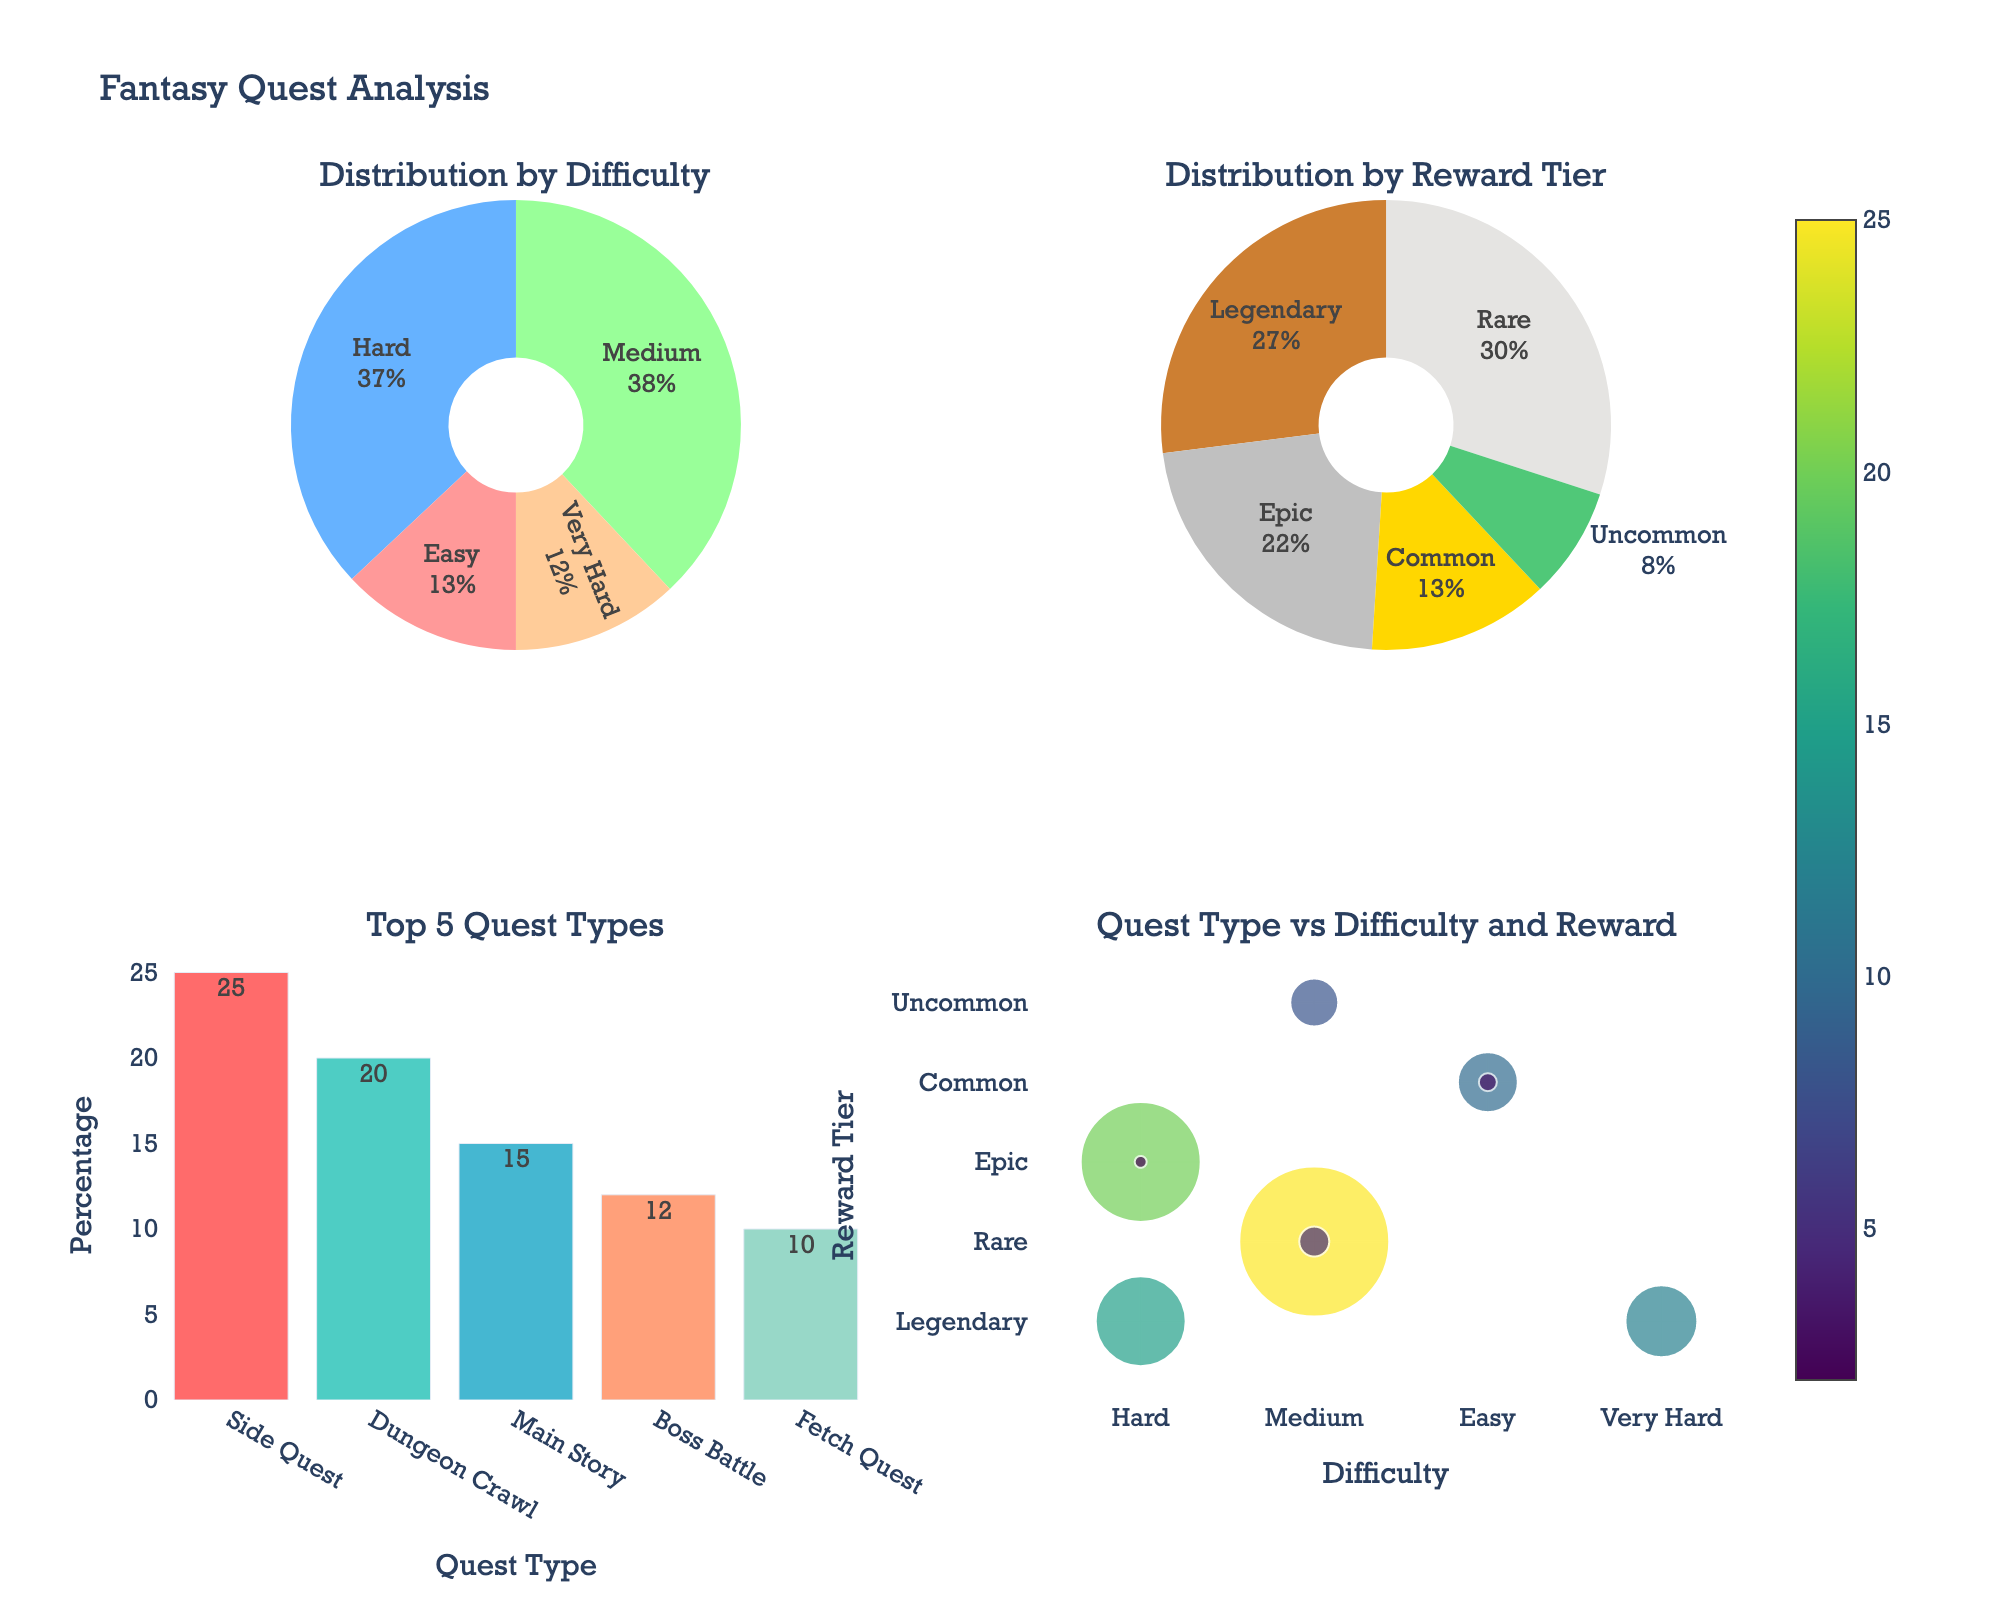What's the most common difficulty level for quests? In the first pie chart, "Distribution by Difficulty," the largest slice represents the "Hard" category, which contributes the most to the percentage.
Answer: Hard Which reward tier has the highest percentage of quests? In the second pie chart, "Distribution by Reward Tier," the biggest section belongs to the "Rare" reward tier.
Answer: Rare Which quest type has the highest percentage according to the bar chart? The bar chart for "Top 5 Quest Types" shows the tallest bar for "Side Quest," indicating it has the highest percentage.
Answer: Side Quest What percentage of quests are considered "Legendary" in terms of rewards? The second pie chart shows two "Legendary" sections: one in "Main Story" (15%) and one in "Boss Battle" (12%). Adding these gives 15 + 12 = 27.
Answer: 27% Which quest type in the "Top 5 Quest Types" has the smallest percentage? According to the bar chart, "Puzzle Solving" has the smallest bar among the "Top 5 Quest Types," representing the smallest percentage.
Answer: Puzzle Solving How do the percentages of "Dungeon Crawl" and "Boss Battle" quests compare? From the bar chart, "Dungeon Crawl" is at 20% while "Boss Battle" is at 12%, indicating that "Dungeon Crawl" has a higher percentage.
Answer: Dungeon Crawl has a higher percentage than Boss Battle Which two difficulty levels combined make up the majority of the quest percentages? Adding the percentages from the first pie chart: "Hard" (37%) and "Medium" (38%). Together they make 37 + 38 = 75.
Answer: Hard and Medium What quest type is represented by the largest marker in the scatter plot, indicating a high percentage? The scatter plot in the fourth subplot shows the largest marker for "Side Quest," corresponding to 25%.
Answer: Side Quest How many quest types fall under the "Epic" reward tier and what are they? In the scatter plot (last subplot), "Dungeon Crawl" and "Time Trial" lie on the row for the "Epic" reward tier.
Answer: 2, Dungeon Crawl and Time Trial What are the smallest and largest percentages for quest types in the "Top 5 Quest Types" chart? The "Top 5 Quest Types" chart shows the smallest percentage for "Puzzle Solving" (5%) and the largest for "Side Quest" (25%).
Answer: Smallest: 5%, Largest: 25% 